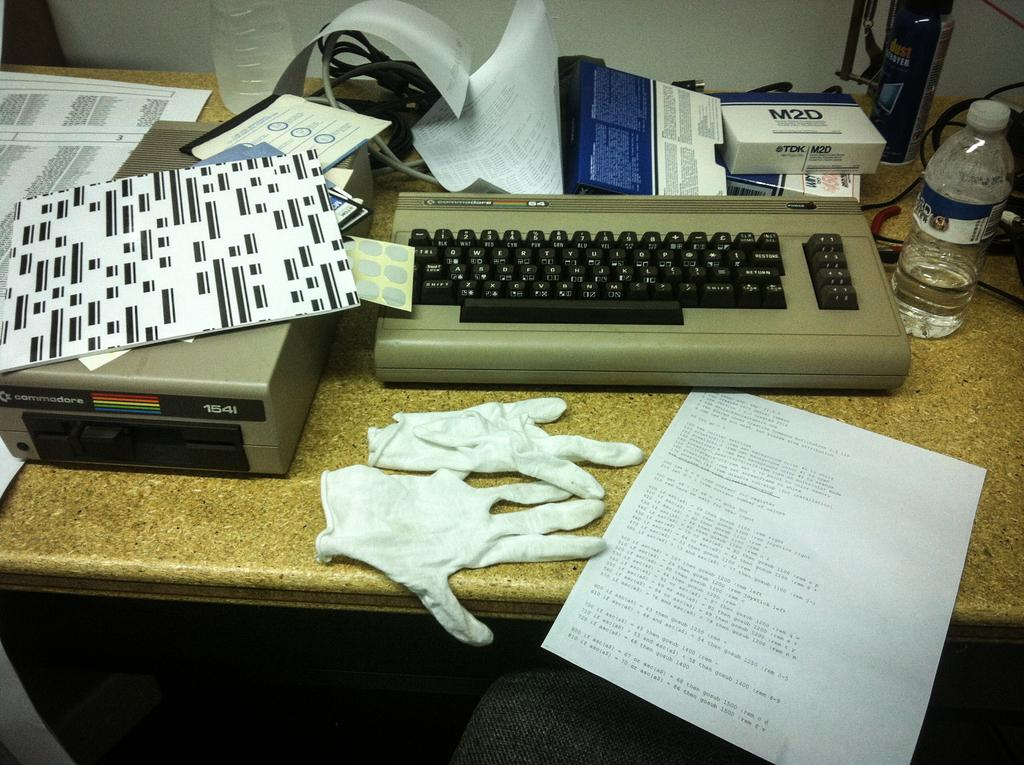<image>
Create a compact narrative representing the image presented. On a desk somewhere sits a keyboard and other components of a Commodore 64. 